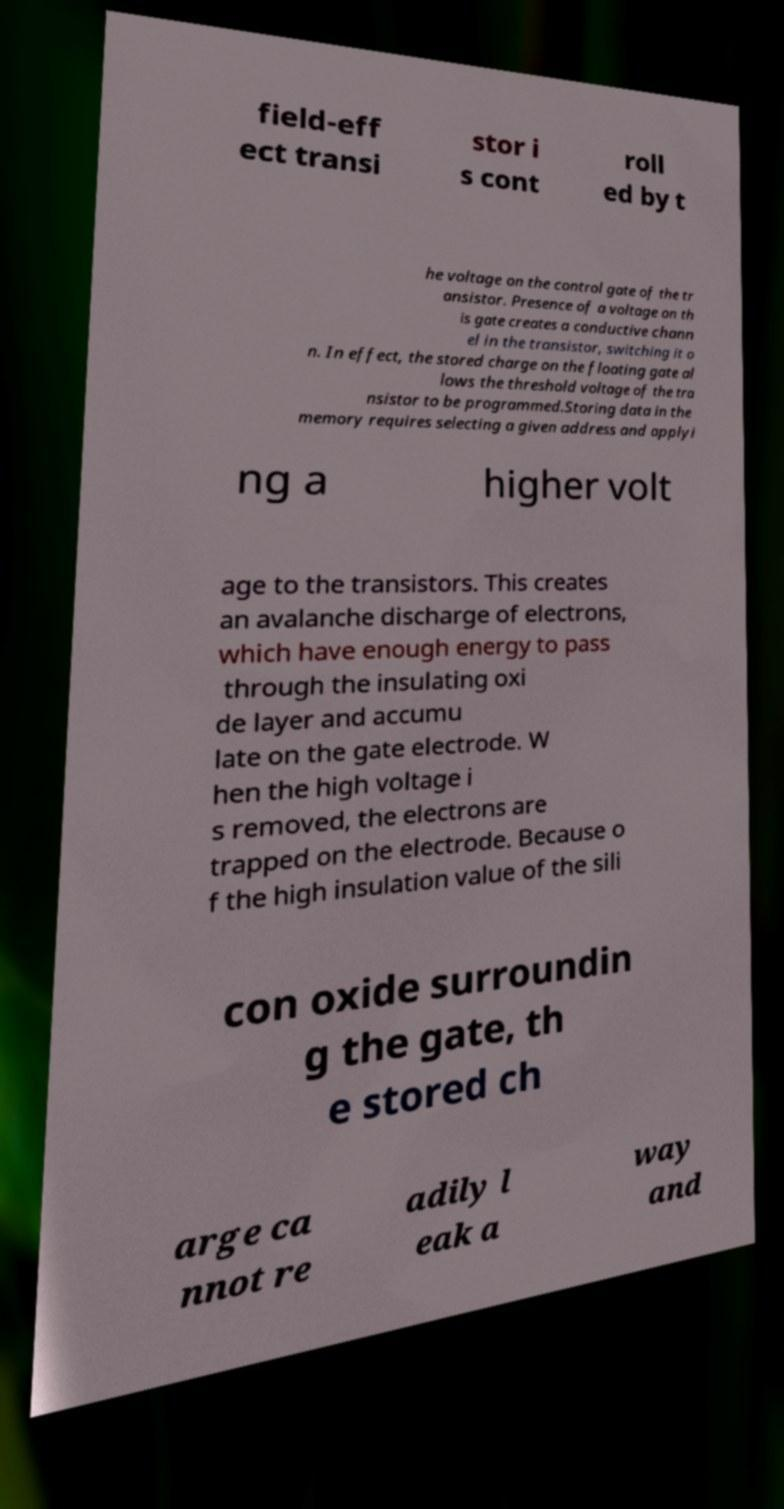Can you read and provide the text displayed in the image?This photo seems to have some interesting text. Can you extract and type it out for me? field-eff ect transi stor i s cont roll ed by t he voltage on the control gate of the tr ansistor. Presence of a voltage on th is gate creates a conductive chann el in the transistor, switching it o n. In effect, the stored charge on the floating gate al lows the threshold voltage of the tra nsistor to be programmed.Storing data in the memory requires selecting a given address and applyi ng a higher volt age to the transistors. This creates an avalanche discharge of electrons, which have enough energy to pass through the insulating oxi de layer and accumu late on the gate electrode. W hen the high voltage i s removed, the electrons are trapped on the electrode. Because o f the high insulation value of the sili con oxide surroundin g the gate, th e stored ch arge ca nnot re adily l eak a way and 